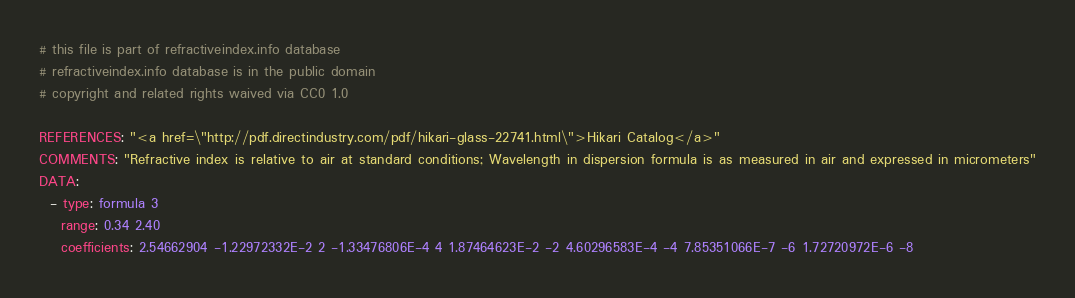Convert code to text. <code><loc_0><loc_0><loc_500><loc_500><_YAML_># this file is part of refractiveindex.info database
# refractiveindex.info database is in the public domain
# copyright and related rights waived via CC0 1.0

REFERENCES: "<a href=\"http://pdf.directindustry.com/pdf/hikari-glass-22741.html\">Hikari Catalog</a>"
COMMENTS: "Refractive index is relative to air at standard conditions; Wavelength in dispersion formula is as measured in air and expressed in micrometers"
DATA:
  - type: formula 3
    range: 0.34 2.40
    coefficients: 2.54662904 -1.22972332E-2 2 -1.33476806E-4 4 1.87464623E-2 -2 4.60296583E-4 -4 7.85351066E-7 -6 1.72720972E-6 -8
</code> 